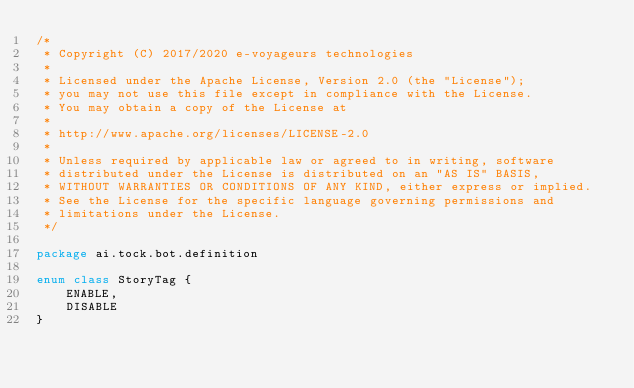<code> <loc_0><loc_0><loc_500><loc_500><_Kotlin_>/*
 * Copyright (C) 2017/2020 e-voyageurs technologies
 *
 * Licensed under the Apache License, Version 2.0 (the "License");
 * you may not use this file except in compliance with the License.
 * You may obtain a copy of the License at
 *
 * http://www.apache.org/licenses/LICENSE-2.0
 *
 * Unless required by applicable law or agreed to in writing, software
 * distributed under the License is distributed on an "AS IS" BASIS,
 * WITHOUT WARRANTIES OR CONDITIONS OF ANY KIND, either express or implied.
 * See the License for the specific language governing permissions and
 * limitations under the License.
 */

package ai.tock.bot.definition

enum class StoryTag {
    ENABLE,
    DISABLE
}
</code> 